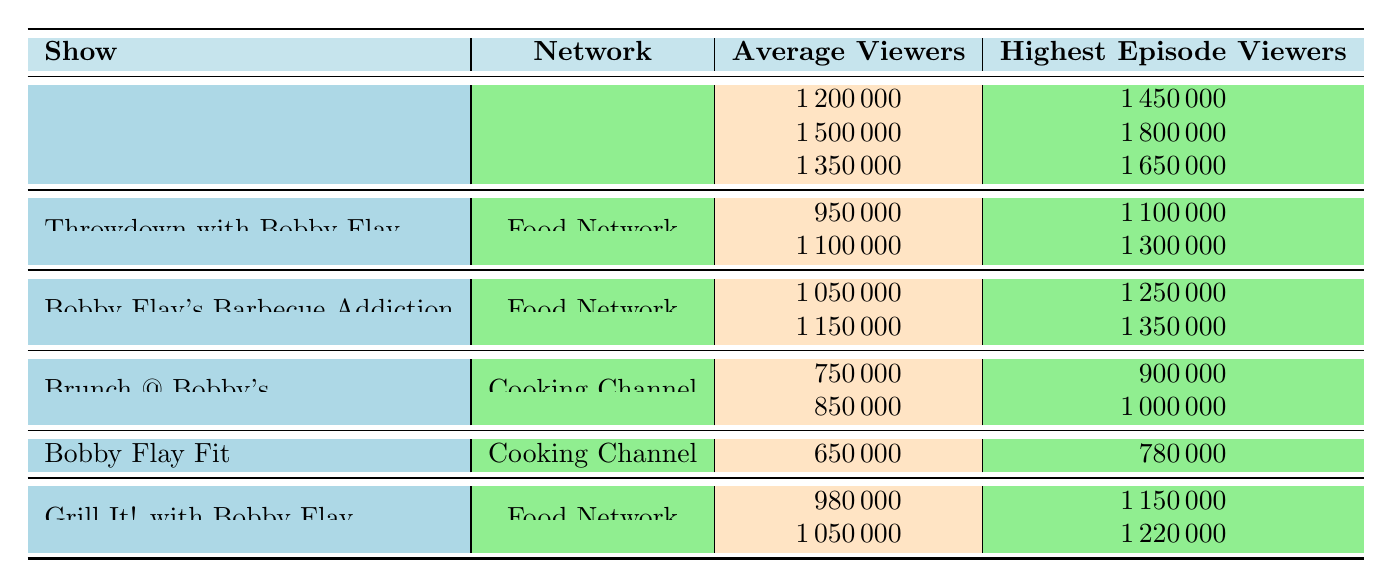What's the average viewership for "Beat Bobby Flay" in Season 5? The table shows that "Beat Bobby Flay" in Season 5 has an average viewer count of 1500000.
Answer: 1500000 Which show had the highest average viewers across seasons in the Food Network? By comparing the average viewers from all shows in the Food Network, "Beat Bobby Flay" Season 5 has the highest at 1500000, followed by its other seasons.
Answer: Beat Bobby Flay Did "Bobby Flay Fit" have a higher average viewership than "Brunch @ Bobby's"? "Bobby Flay Fit" has an average viewership of 650000, while "Brunch @ Bobby's" has 750000, making the statement false.
Answer: No What is the total average viewership of all seasons for "Throwdown with Bobby Flay"? The average viewership is 950000 for Season 1 and 1100000 for Season 5. Adding them: 950000 + 1100000 = 2050000. The average is then 2050000 / 2 = 1025000.
Answer: 1025000 In what year did "Bobby Flay's Barbecue Addiction" achieve its second-highest episode viewership? The second-highest episode viewership is 1350000 in Season 4, which aired in 2014.
Answer: 2014 What was the highest-rated episode of "Brunch @ Bobby's"? The table lists "Brunch Fiesta" as the highest-rated episode of "Brunch @ Bobby's".
Answer: Brunch Fiesta Which show received more viewers in its highest episode, "Grill It! with Bobby Flay" Season 1 or Season 3? Season 3 had 1220000 viewers while Season 1 had 1150000 viewers. Therefore, Season 3 had more viewers.
Answer: Season 3 What is the difference in average viewers between "Grill It! with Bobby Flay" Season 1 and "Bobby Flay's Barbecue Addiction" Season 1? Season 1 of "Grill It!" has 980000 viewers, while "Barbecue Addiction" has 1050000. The difference is 1050000 - 980000 = 70000.
Answer: 70000 Which show had the lowest number of average viewers? Among all shows, "Bobby Flay Fit" with 650000 viewers has the lowest average viewership.
Answer: Bobby Flay Fit 